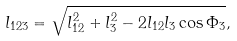Convert formula to latex. <formula><loc_0><loc_0><loc_500><loc_500>l _ { 1 2 3 } = \sqrt { l _ { 1 2 } ^ { 2 } + l _ { 3 } ^ { 2 } - 2 l _ { 1 2 } l _ { 3 } \cos \Phi _ { 3 } } ,</formula> 